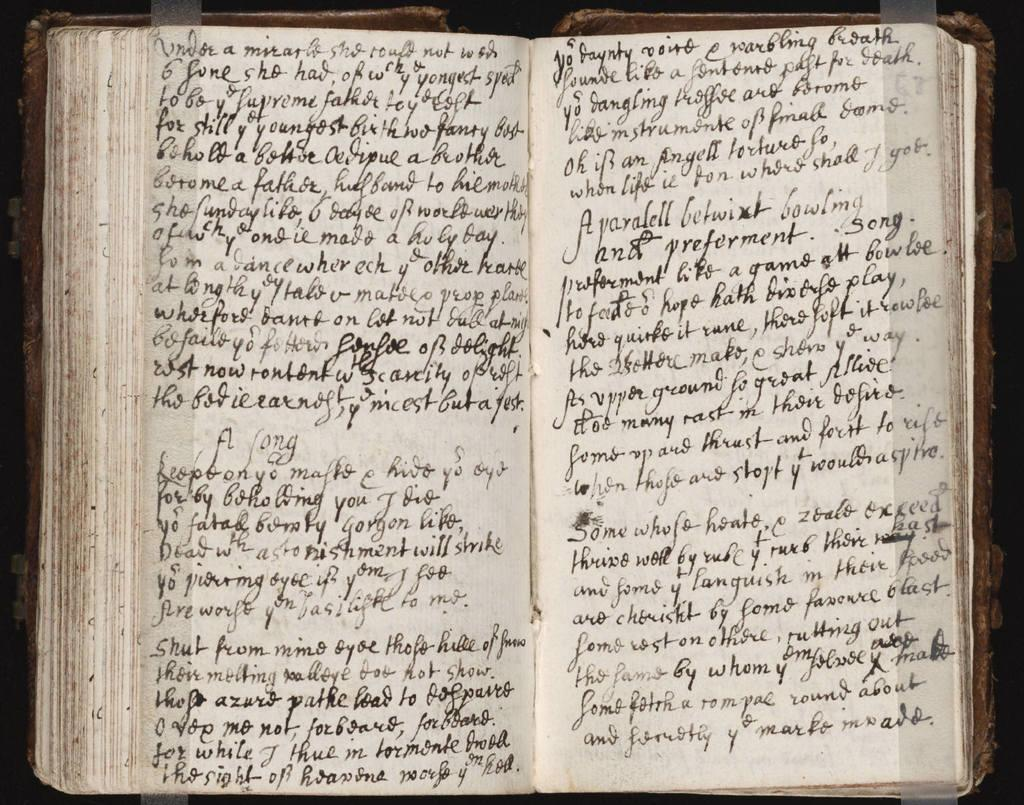What is the main object in the image? There is a book in the image. What other items can be seen in the image? There are papers with text in the image. How are the papers with text connected or secured? Transparent tape is pasted on both papers. What type of nerve can be seen in the image? There is no nerve present in the image. Where is the mailbox located in the image? There is no mailbox present in the image. 